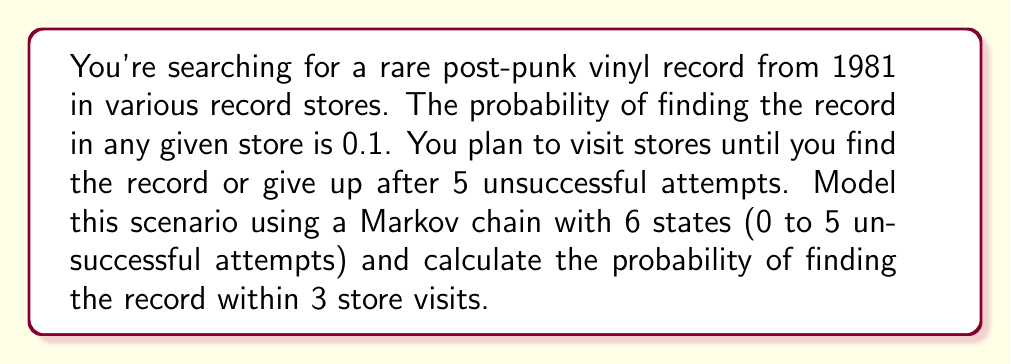Can you solve this math problem? Let's approach this step-by-step:

1) First, we need to define our Markov chain. We have 6 states:
   State 0: Start
   States 1-4: Number of unsuccessful attempts
   State 5: Give up (absorbing state)

2) The transition matrix P for this Markov chain is:

   $$P = \begin{bmatrix}
   0 & 0.9 & 0 & 0 & 0 & 0.1 \\
   0 & 0 & 0.9 & 0 & 0 & 0.1 \\
   0 & 0 & 0 & 0.9 & 0 & 0.1 \\
   0 & 0 & 0 & 0 & 0.9 & 0.1 \\
   0 & 0 & 0 & 0 & 0 & 1 \\
   0 & 0 & 0 & 0 & 0 & 1
   \end{bmatrix}$$

   Where the last column represents finding the record (absorbing state).

3) To find the probability of finding the record within 3 visits, we need to calculate $P^3$ and sum the probabilities in the last column for rows 0-3.

4) Let's calculate $P^3$:

   $$P^3 = \begin{bmatrix}
   0 & 0 & 0.729 & 0.243 & 0 & 0.271 \\
   0 & 0 & 0 & 0.729 & 0.243 & 0.271 \\
   0 & 0 & 0 & 0 & 0.729 & 0.271 \\
   0 & 0 & 0 & 0 & 0 & 1 \\
   0 & 0 & 0 & 0 & 0 & 1 \\
   0 & 0 & 0 & 0 & 0 & 1
   \end{bmatrix}$$

5) The probability of finding the record within 3 visits is the sum of the last column entries for rows 0-3:

   $0.271 + 0.271 + 0.271 + 1 = 0.813$

Therefore, the probability of finding the rare post-punk vinyl record within 3 store visits is 0.813 or 81.3%.
Answer: 0.813 